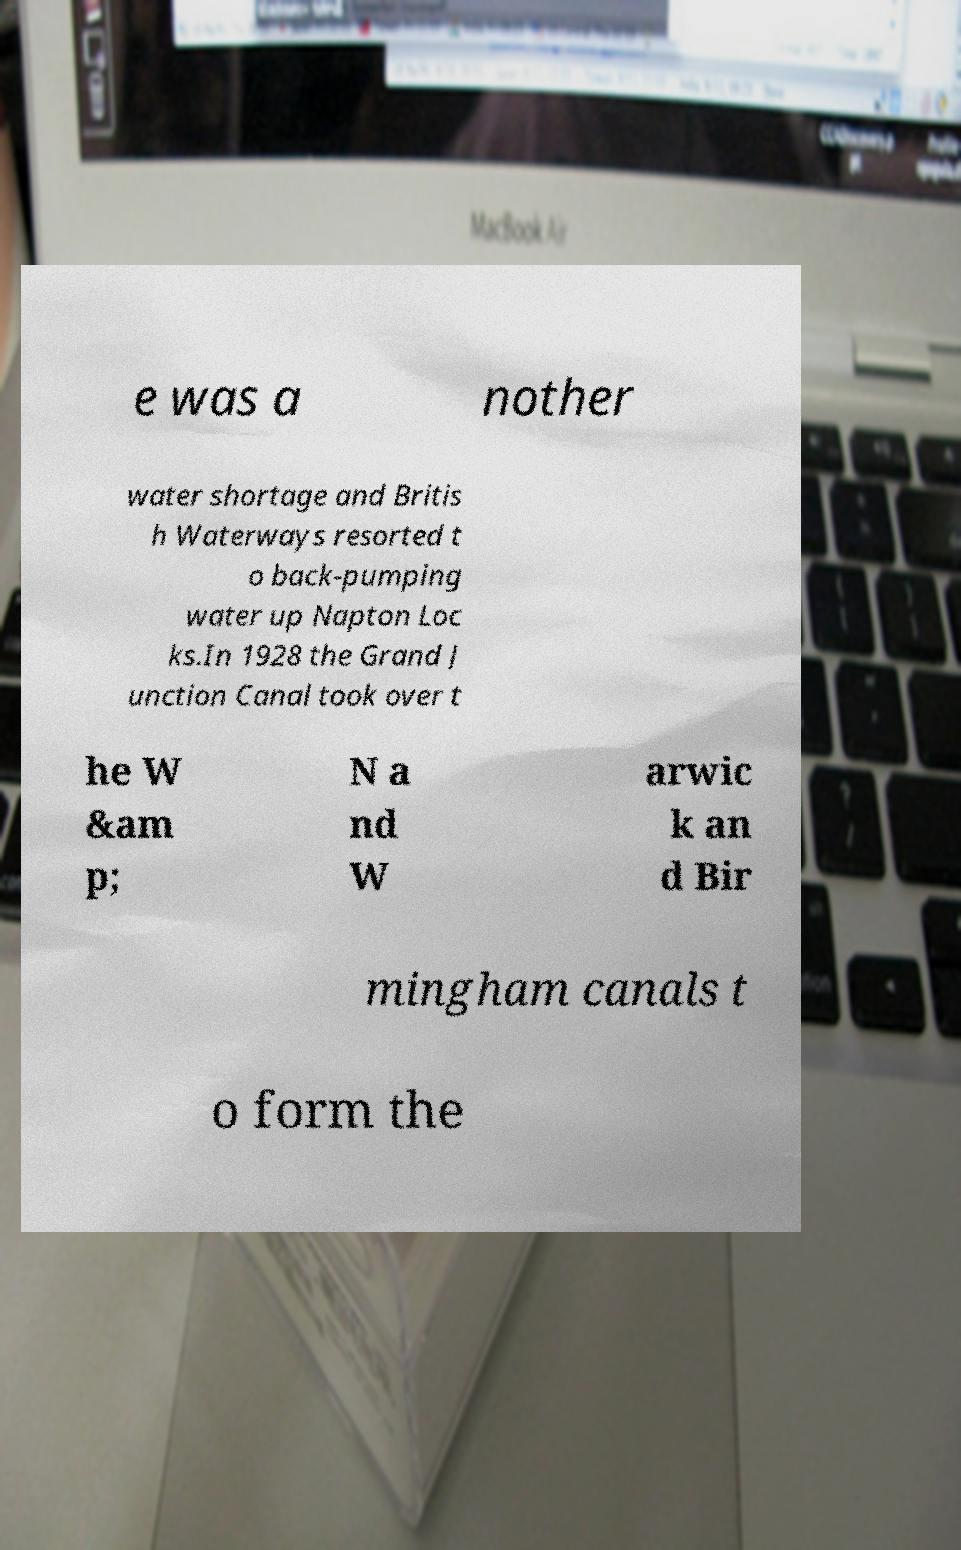What messages or text are displayed in this image? I need them in a readable, typed format. e was a nother water shortage and Britis h Waterways resorted t o back-pumping water up Napton Loc ks.In 1928 the Grand J unction Canal took over t he W &am p; N a nd W arwic k an d Bir mingham canals t o form the 